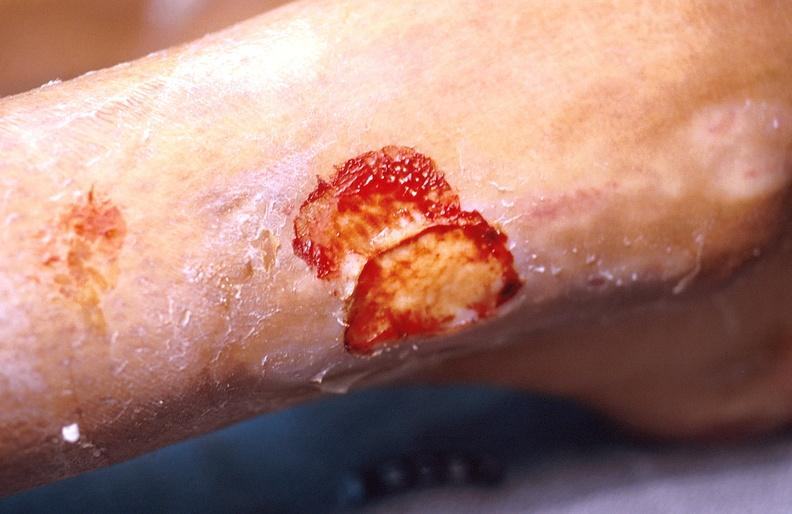does this image show cellulitis?
Answer the question using a single word or phrase. Yes 